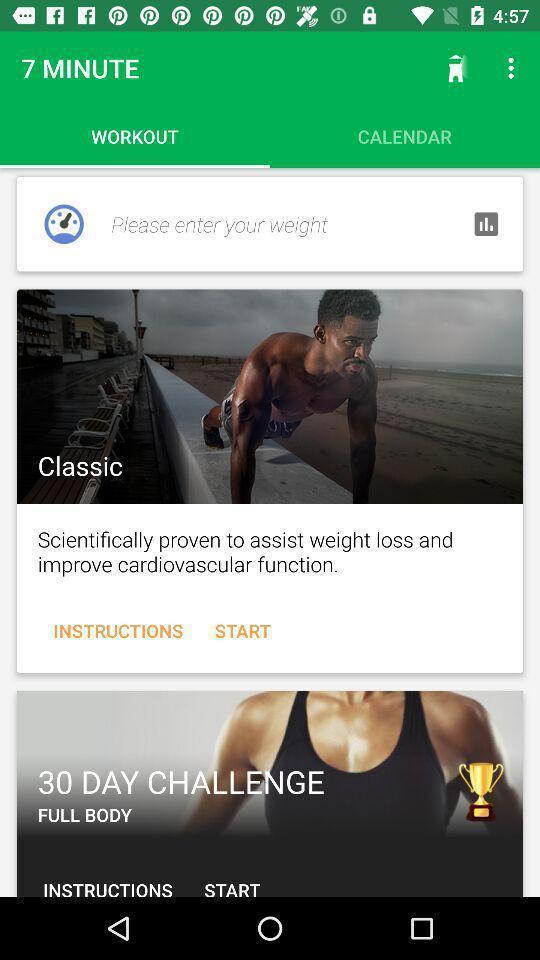Describe the content in this image. Various workout info displayed of a fitness training app. 